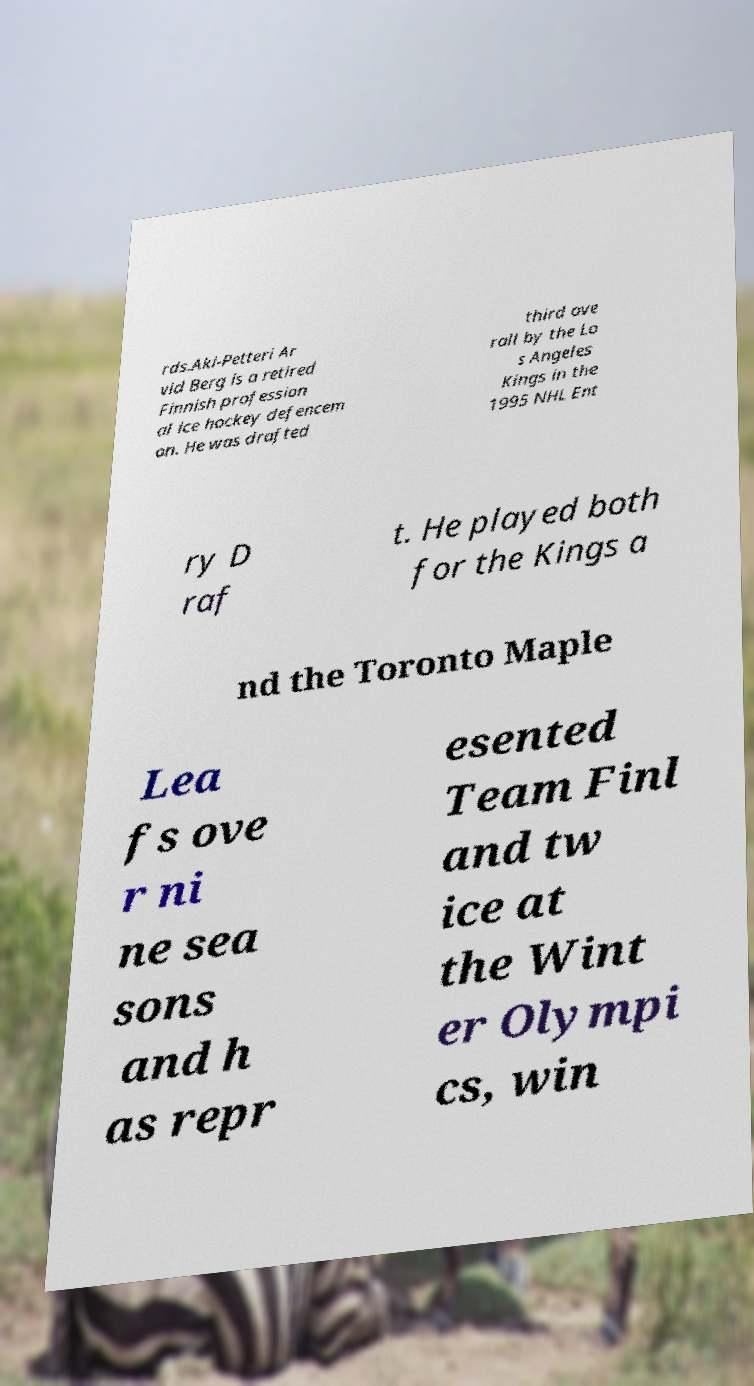I need the written content from this picture converted into text. Can you do that? rds.Aki-Petteri Ar vid Berg is a retired Finnish profession al ice hockey defencem an. He was drafted third ove rall by the Lo s Angeles Kings in the 1995 NHL Ent ry D raf t. He played both for the Kings a nd the Toronto Maple Lea fs ove r ni ne sea sons and h as repr esented Team Finl and tw ice at the Wint er Olympi cs, win 